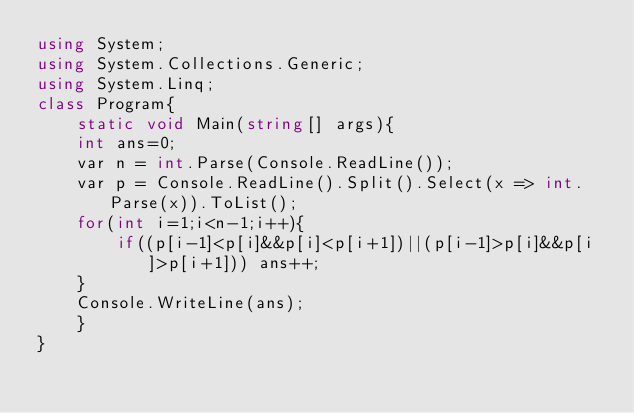<code> <loc_0><loc_0><loc_500><loc_500><_C#_>using System;
using System.Collections.Generic;
using System.Linq;
class Program{
    static void Main(string[] args){
    int ans=0;
    var n = int.Parse(Console.ReadLine());
    var p = Console.ReadLine().Split().Select(x => int.Parse(x)).ToList();
    for(int i=1;i<n-1;i++){
        if((p[i-1]<p[i]&&p[i]<p[i+1])||(p[i-1]>p[i]&&p[i]>p[i+1])) ans++;
    }
    Console.WriteLine(ans);
    }
}</code> 